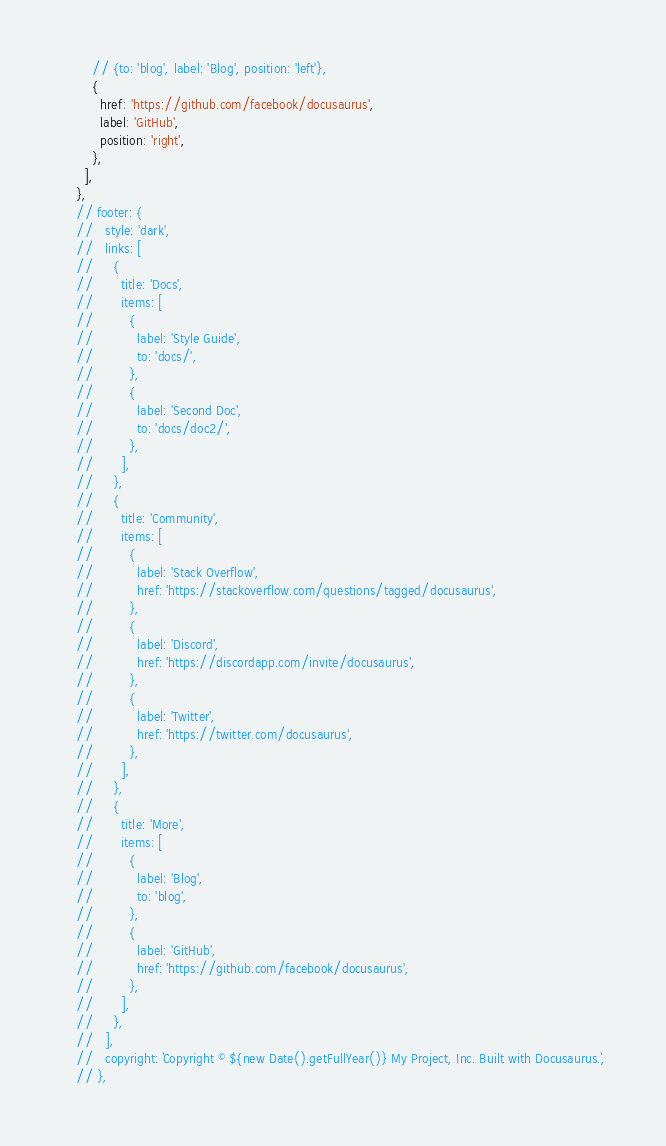Convert code to text. <code><loc_0><loc_0><loc_500><loc_500><_JavaScript_>        // {to: 'blog', label: 'Blog', position: 'left'},
        {
          href: 'https://github.com/facebook/docusaurus',
          label: 'GitHub',
          position: 'right',
        },
      ],
    },
    // footer: {
    //   style: 'dark',
    //   links: [
    //     {
    //       title: 'Docs',
    //       items: [
    //         {
    //           label: 'Style Guide',
    //           to: 'docs/',
    //         },
    //         {
    //           label: 'Second Doc',
    //           to: 'docs/doc2/',
    //         },
    //       ],
    //     },
    //     {
    //       title: 'Community',
    //       items: [
    //         {
    //           label: 'Stack Overflow',
    //           href: 'https://stackoverflow.com/questions/tagged/docusaurus',
    //         },
    //         {
    //           label: 'Discord',
    //           href: 'https://discordapp.com/invite/docusaurus',
    //         },
    //         {
    //           label: 'Twitter',
    //           href: 'https://twitter.com/docusaurus',
    //         },
    //       ],
    //     },
    //     {
    //       title: 'More',
    //       items: [
    //         {
    //           label: 'Blog',
    //           to: 'blog',
    //         },
    //         {
    //           label: 'GitHub',
    //           href: 'https://github.com/facebook/docusaurus',
    //         },
    //       ],
    //     },
    //   ],
    //   copyright: `Copyright © ${new Date().getFullYear()} My Project, Inc. Built with Docusaurus.`,
    // },</code> 